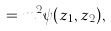<formula> <loc_0><loc_0><loc_500><loc_500>= m ^ { 2 } \psi ( z _ { 1 } , z _ { 2 } ) ,</formula> 